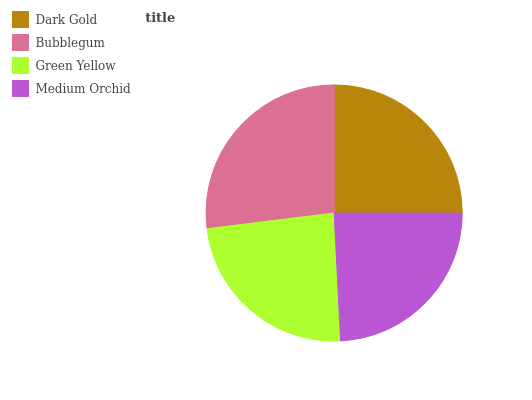Is Green Yellow the minimum?
Answer yes or no. Yes. Is Bubblegum the maximum?
Answer yes or no. Yes. Is Bubblegum the minimum?
Answer yes or no. No. Is Green Yellow the maximum?
Answer yes or no. No. Is Bubblegum greater than Green Yellow?
Answer yes or no. Yes. Is Green Yellow less than Bubblegum?
Answer yes or no. Yes. Is Green Yellow greater than Bubblegum?
Answer yes or no. No. Is Bubblegum less than Green Yellow?
Answer yes or no. No. Is Dark Gold the high median?
Answer yes or no. Yes. Is Medium Orchid the low median?
Answer yes or no. Yes. Is Green Yellow the high median?
Answer yes or no. No. Is Dark Gold the low median?
Answer yes or no. No. 